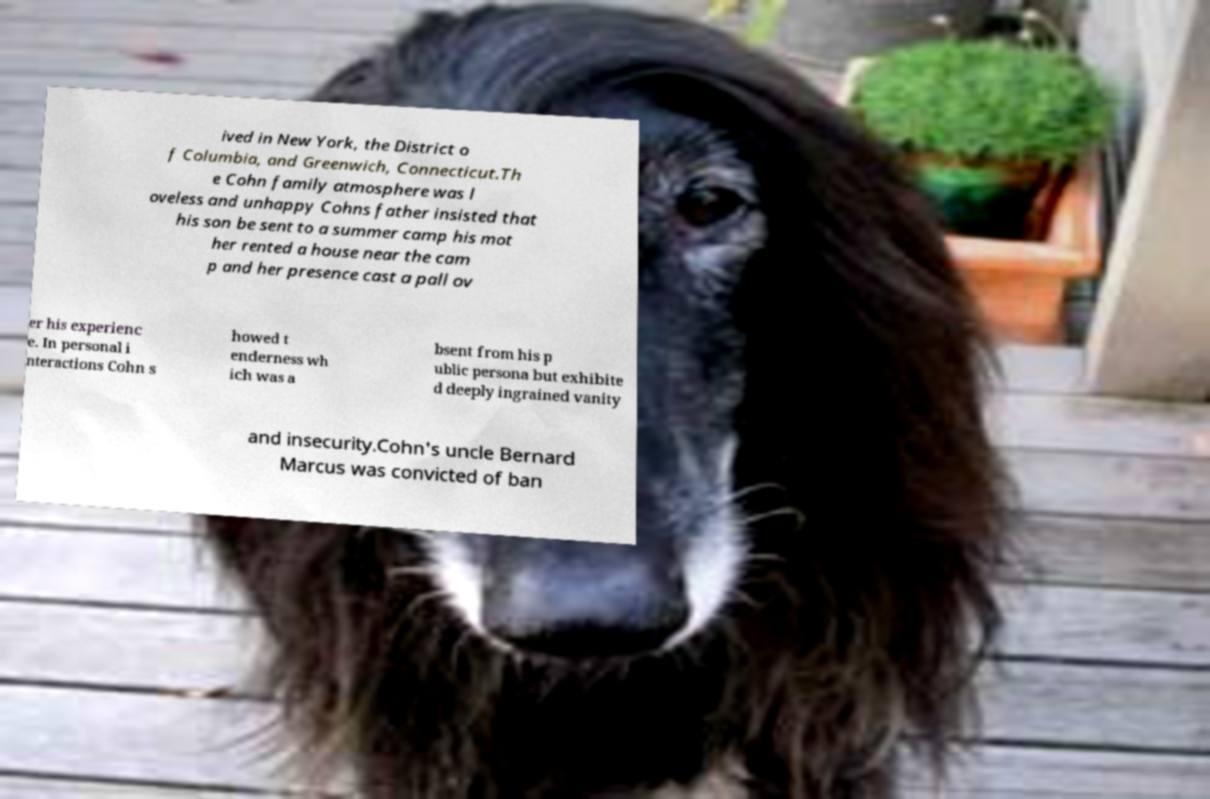For documentation purposes, I need the text within this image transcribed. Could you provide that? ived in New York, the District o f Columbia, and Greenwich, Connecticut.Th e Cohn family atmosphere was l oveless and unhappy Cohns father insisted that his son be sent to a summer camp his mot her rented a house near the cam p and her presence cast a pall ov er his experienc e. In personal i nteractions Cohn s howed t enderness wh ich was a bsent from his p ublic persona but exhibite d deeply ingrained vanity and insecurity.Cohn's uncle Bernard Marcus was convicted of ban 